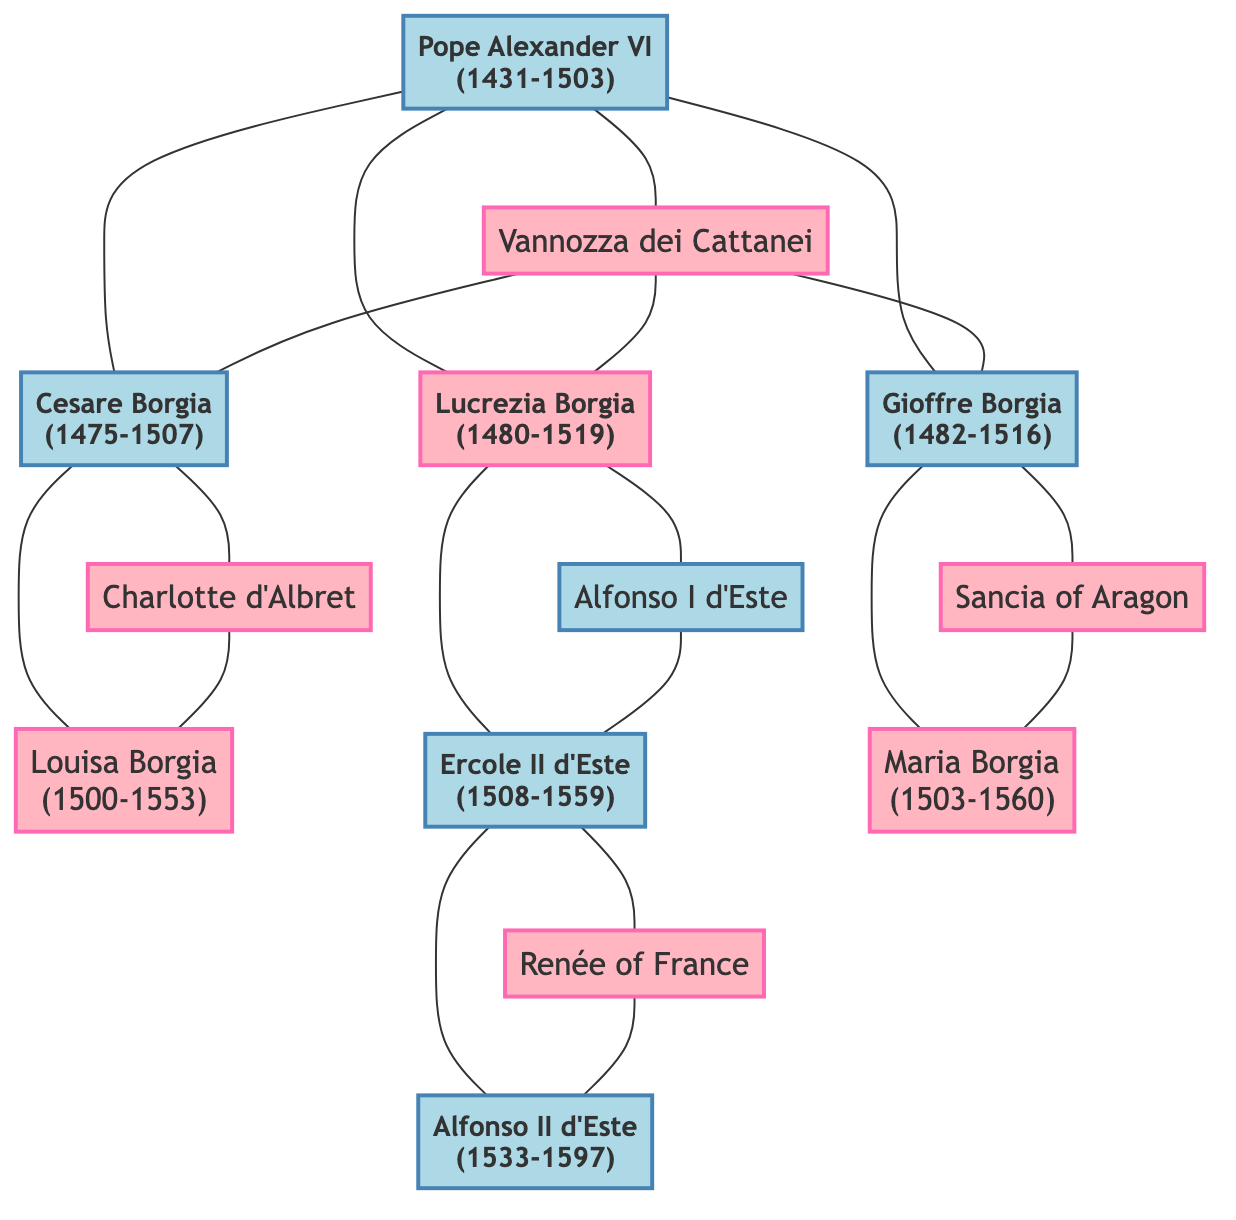What is the birth year of Pope Alexander VI? The diagram indicates that Pope Alexander VI was born in 1431. This information is directly stated in the node representing him.
Answer: 1431 Who is the spouse of Lucrezia Borgia? According to the diagram, Lucrezia Borgia is married to Alfonso I d'Este. This connection is illustrated through the link between their nodes.
Answer: Alfonso I d'Este How many children did Cesare Borgia have? From the diagram, we see that Cesare Borgia has one child, Louisa Borgia. This is evident from the child node connected to Cesare's node.
Answer: 1 Which title is held by Ercole II d'Este? The diagram shows the title associated with Ercole II d'Este is "Duke of Ferrara." This title is specifically mentioned next to his name in the diagram.
Answer: Duke of Ferrara What is the relationship between Maria Borgia and Pope Alexander VI? The diagram illustrates that Maria Borgia is the granddaughter of Pope Alexander VI. This is derived from her parent, Gioffre Borgia, being a child of Pope Alexander VI, leading to the conclusion that Maria is his granddaughter.
Answer: Granddaughter Who are the parents of Alfonso II d'Este? The diagram reveals that the parents of Alfonso II d'Este are Ercole II d'Este and Renée of France. This can be traced through the child node connected to their respective nodes.
Answer: Ercole II d'Este and Renée of France What generation does Cesare Borgia belong to? The diagram categorizes Cesare Borgia as part of "Generation 2." This is determined by the placement of his node within the second generation block.
Answer: Generation 2 How many generations are represented in the family tree? The diagram clearly shows three generations depicted: Generation 1, Generation 2, and Generation 3. This can be counted from the headers identifying each generation.
Answer: 3 